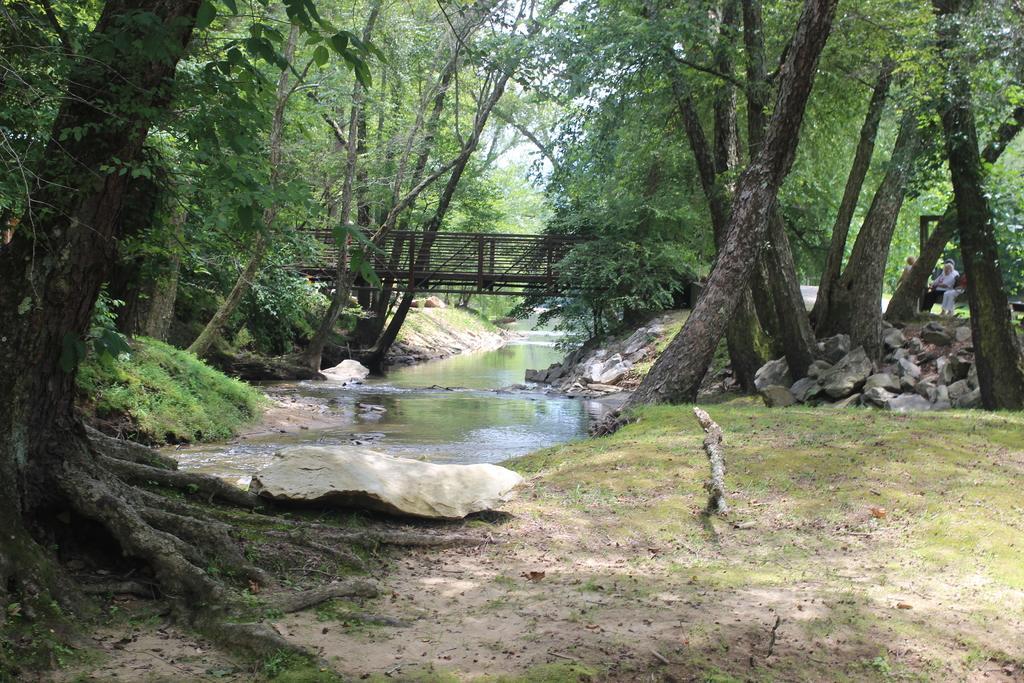Describe this image in one or two sentences. In the image we can see there are many trees and stones. There is a grass, wooden pole, water and a white sky. We can even see there are people sitting and they are wearing clothes. 